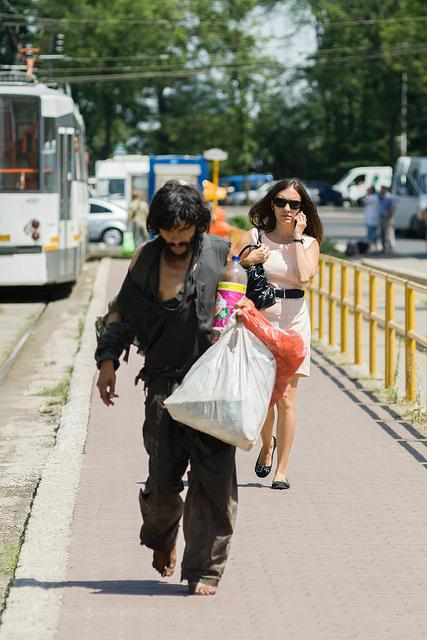What type of phone is the woman using?

Choices:
A) landline
B) rotary
C) pay
D) cellular cellular 